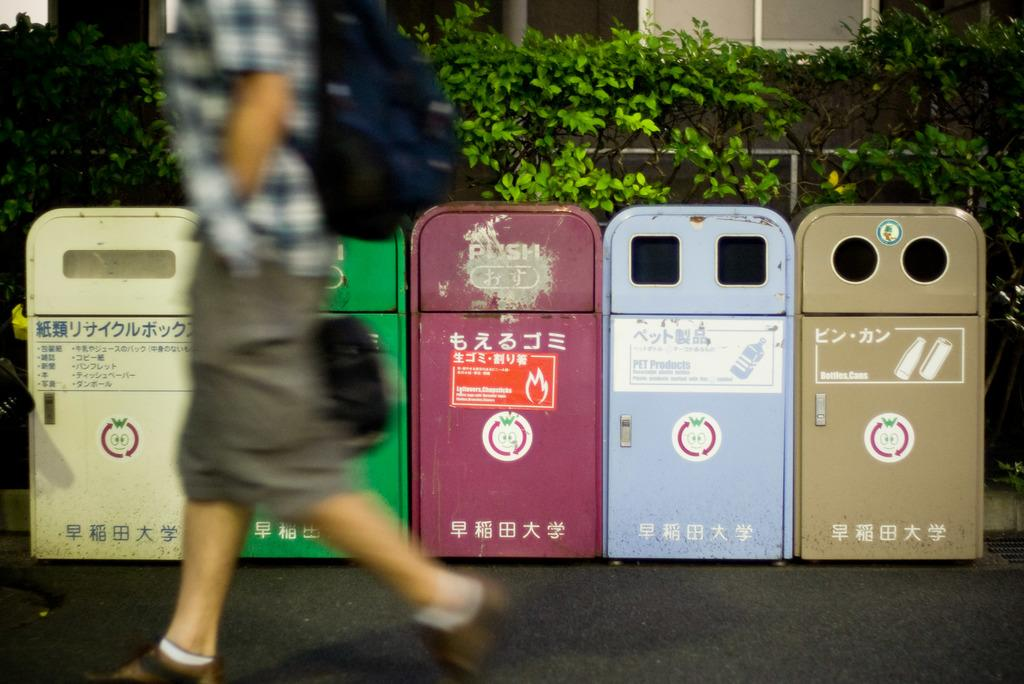<image>
Share a concise interpretation of the image provided. Five multi colored trashcans outside with the purple one in the center reading "push" near the top. 